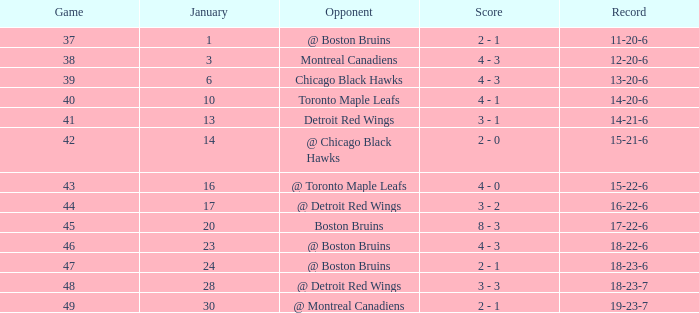What was the total number of games on January 20? 1.0. 